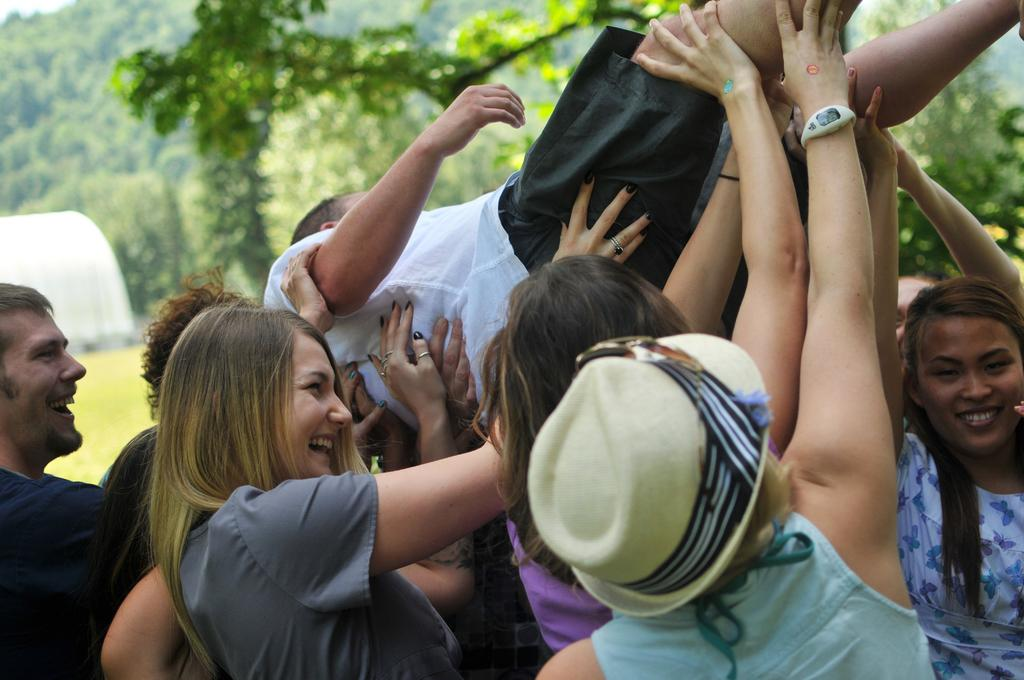How many people are in the image? There are many people in the image. What are the people doing in the image? The people are lifting a person. What is the facial expression of the people in the image? The people are smiling. What can be seen in the background of the image? There are trees in the background of the image. What type of structure is present in the image? There is a tent-like structure in the image. What type of oranges are being used to hold up the person in the image? There are no oranges present in the image; the people are lifting the person without any visible support. 